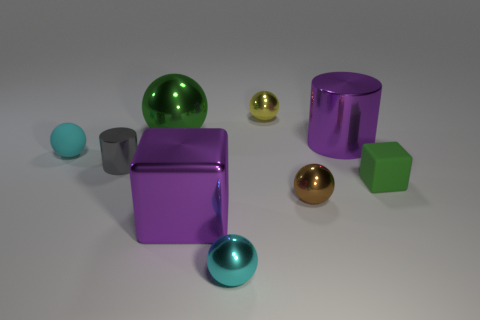Subtract 1 spheres. How many spheres are left? 4 Subtract all green balls. How many balls are left? 4 Subtract all tiny cyan metallic balls. How many balls are left? 4 Subtract all purple spheres. Subtract all yellow cylinders. How many spheres are left? 5 Add 1 tiny yellow shiny blocks. How many objects exist? 10 Subtract all cubes. How many objects are left? 7 Add 9 large green things. How many large green things exist? 10 Subtract 0 gray blocks. How many objects are left? 9 Subtract all big yellow things. Subtract all small cyan shiny spheres. How many objects are left? 8 Add 7 tiny green blocks. How many tiny green blocks are left? 8 